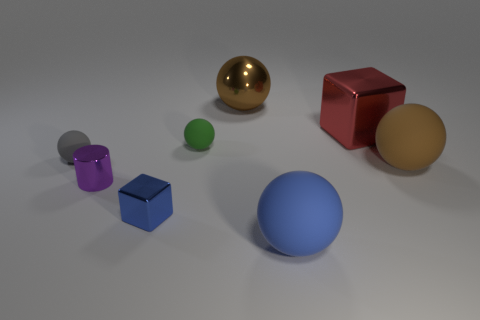There is a small cube; is it the same color as the big rubber thing that is in front of the tiny purple metallic cylinder?
Make the answer very short. Yes. Are there any tiny gray rubber cylinders?
Keep it short and to the point. No. Is the material of the blue ball the same as the tiny sphere that is on the right side of the tiny blue cube?
Offer a very short reply. Yes. There is a cylinder that is the same size as the blue metal object; what is its material?
Offer a terse response. Metal. Is there a tiny object made of the same material as the small purple cylinder?
Offer a very short reply. Yes. Is there a brown metallic object behind the rubber sphere right of the shiny cube right of the brown metal ball?
Give a very brief answer. Yes. There is a metal thing that is the same size as the blue block; what shape is it?
Your answer should be compact. Cylinder. Is the size of the block that is behind the large brown matte thing the same as the matte ball left of the tiny block?
Make the answer very short. No. What number of blue objects are there?
Offer a very short reply. 2. There is a brown thing that is to the left of the large brown object that is in front of the tiny sphere that is on the right side of the small gray matte thing; how big is it?
Keep it short and to the point. Large. 